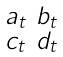<formula> <loc_0><loc_0><loc_500><loc_500>\begin{smallmatrix} a _ { t } & b _ { t } \\ c _ { t } & d _ { t } \end{smallmatrix}</formula> 